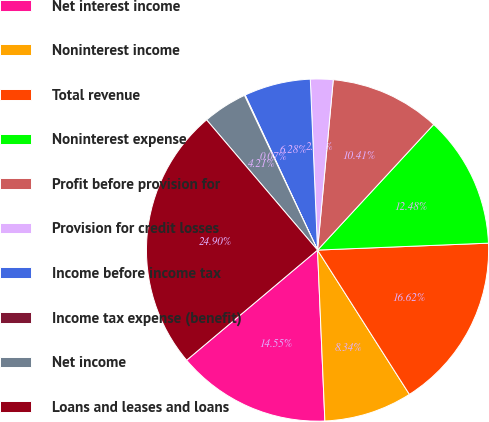Convert chart to OTSL. <chart><loc_0><loc_0><loc_500><loc_500><pie_chart><fcel>Net interest income<fcel>Noninterest income<fcel>Total revenue<fcel>Noninterest expense<fcel>Profit before provision for<fcel>Provision for credit losses<fcel>Income before income tax<fcel>Income tax expense (benefit)<fcel>Net income<fcel>Loans and leases and loans<nl><fcel>14.55%<fcel>8.34%<fcel>16.62%<fcel>12.48%<fcel>10.41%<fcel>2.14%<fcel>6.28%<fcel>0.07%<fcel>4.21%<fcel>24.9%<nl></chart> 